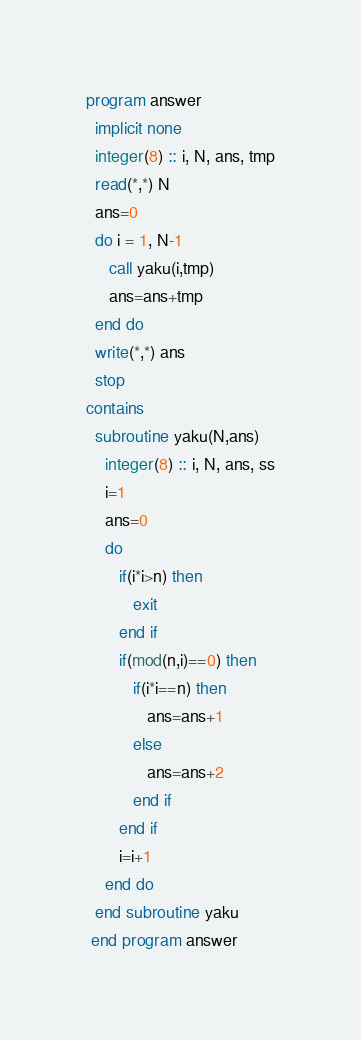<code> <loc_0><loc_0><loc_500><loc_500><_FORTRAN_>program answer
  implicit none
  integer(8) :: i, N, ans, tmp
  read(*,*) N
  ans=0
  do i = 1, N-1
     call yaku(i,tmp)
     ans=ans+tmp
  end do
  write(*,*) ans
  stop
contains
  subroutine yaku(N,ans)
    integer(8) :: i, N, ans, ss
    i=1
    ans=0
    do
       if(i*i>n) then
          exit
       end if
       if(mod(n,i)==0) then
          if(i*i==n) then
             ans=ans+1
          else
             ans=ans+2
          end if
       end if
       i=i+1
    end do
  end subroutine yaku
 end program answer
</code> 